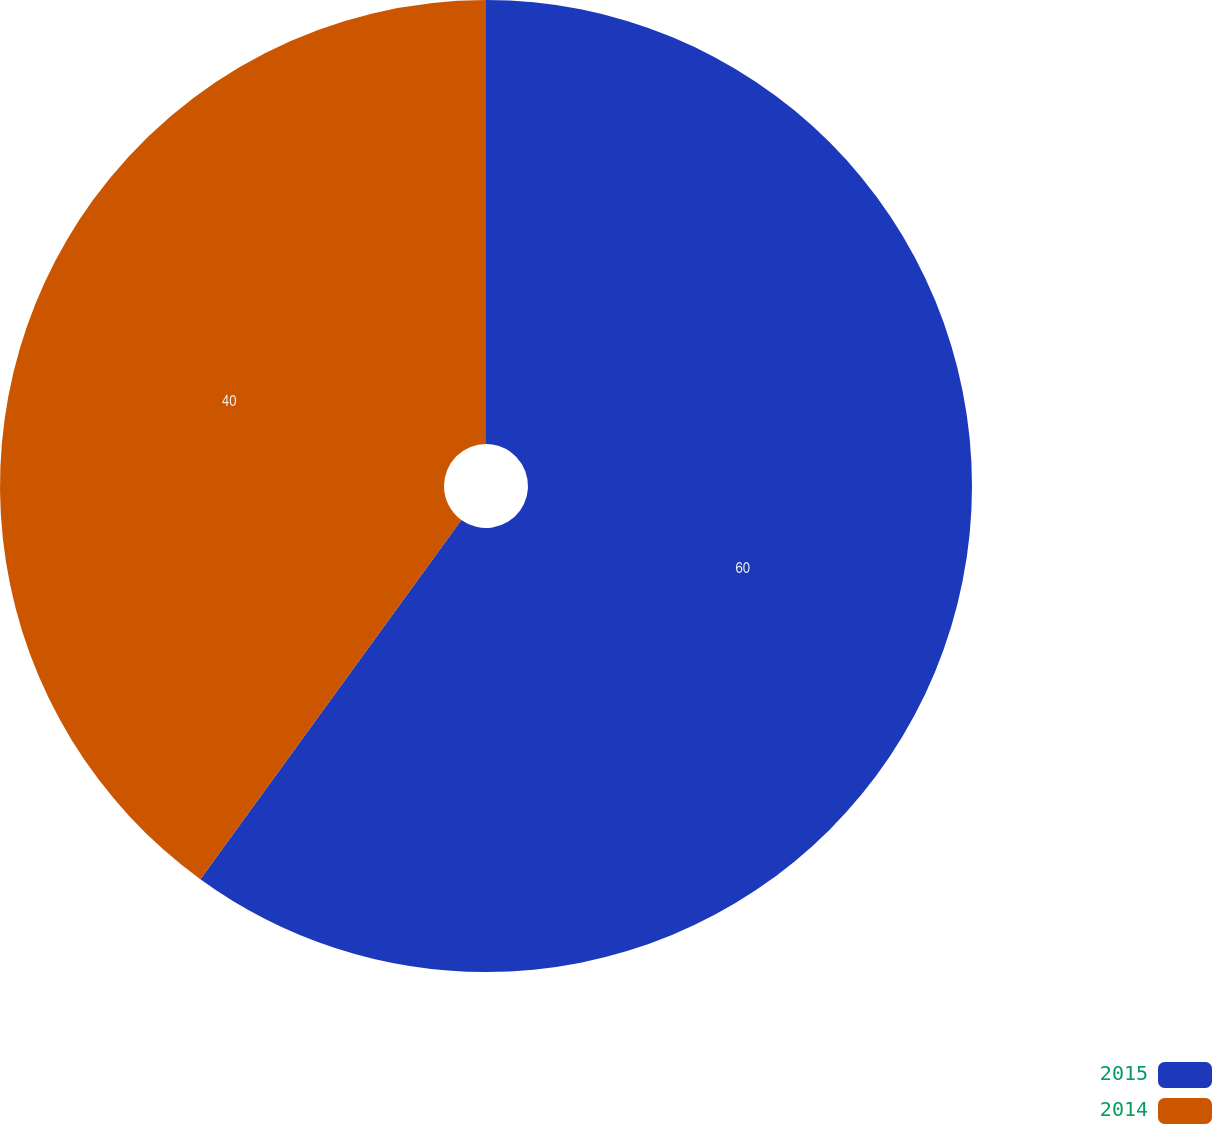Convert chart. <chart><loc_0><loc_0><loc_500><loc_500><pie_chart><fcel>2015<fcel>2014<nl><fcel>60.0%<fcel>40.0%<nl></chart> 